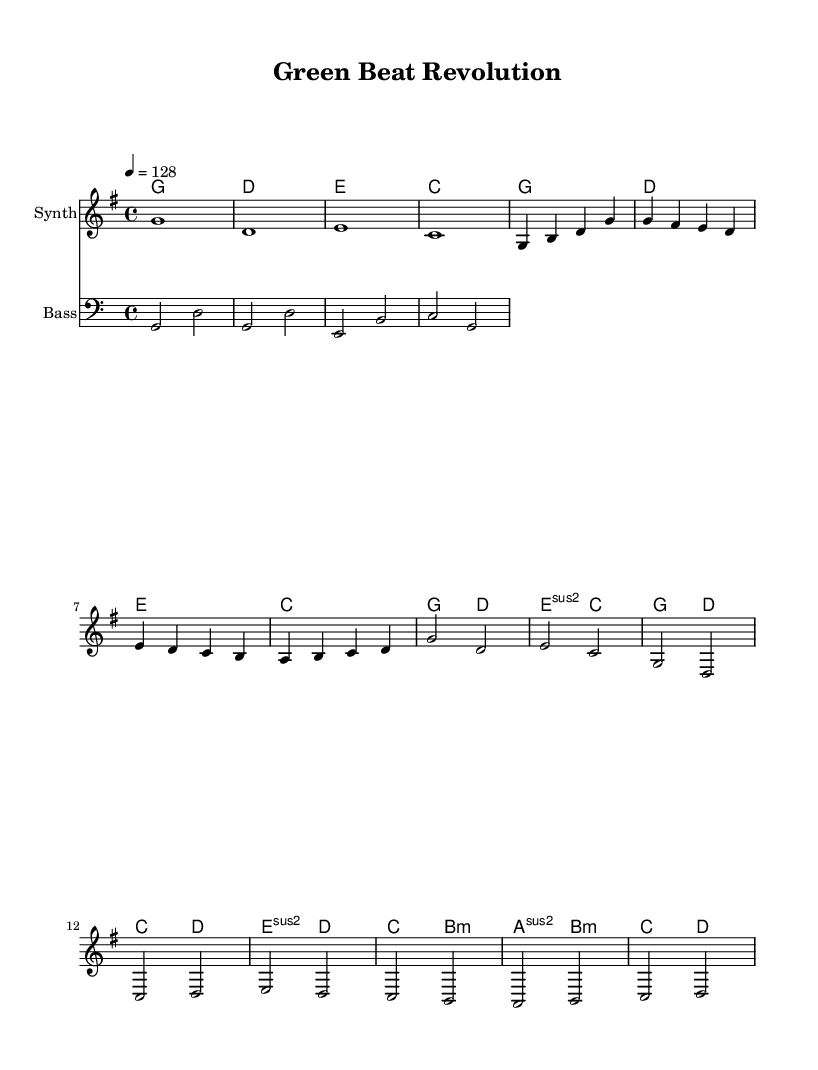What is the key signature of this music? The key signature is G major, which consists of one sharp (F#). This can be determined from the global settings at the beginning of the code, where it indicates the key signature is set to G major.
Answer: G major What is the tempo marking for this piece? The tempo marking is 128 beats per minute, which is indicated in the global settings with the notation "4 = 128". This means there are 128 quarter notes per minute.
Answer: 128 How many measures are there in the chorus section? The chorus section consists of 4 measures, as seen from the melody and harmonies under the chorus label. Each line of the melody is counted, where it clearly shows 4 distinct measures.
Answer: 4 Which chord appears first in the score? The first chord appearing in the score is G major. This is identified in the harmonies section where the first measure is labeled with a G major chord.
Answer: G What is the time signature of the music? The time signature is 4/4, which is defined in the global settings as the time signature of the piece. This means there are four beats in each measure and the quarter note receives one beat.
Answer: 4/4 What instruments are indicated in the score? The score indicates three instruments: ChordNames, Synth, and Bass. This can be identified from the different staff sections where the instruments are named accordingly.
Answer: Synth, Bass How does the bass line relate to the melody? The bass line provides a supportive harmonic foundation that complements the melody. It consists of notes that identify the root of the chords used in the melody, thus creating a cohesive structure. This relationship is crucial in creating the dance music feel.
Answer: Supports the melody 